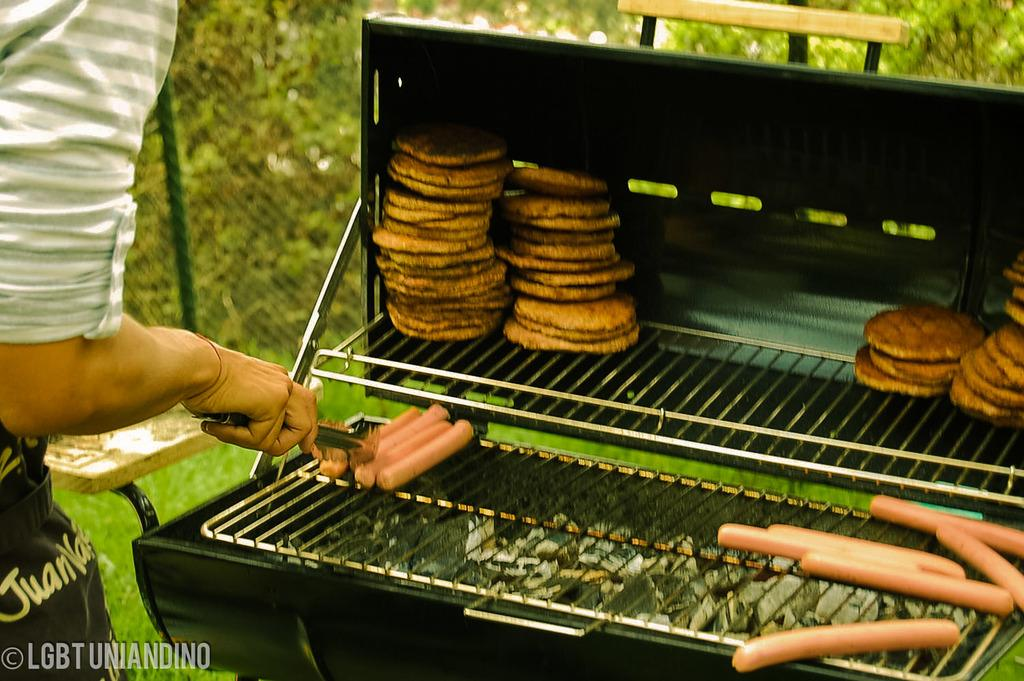<image>
Describe the image concisely. The man operating the grill at a cookout has the name Juan on his apron. 